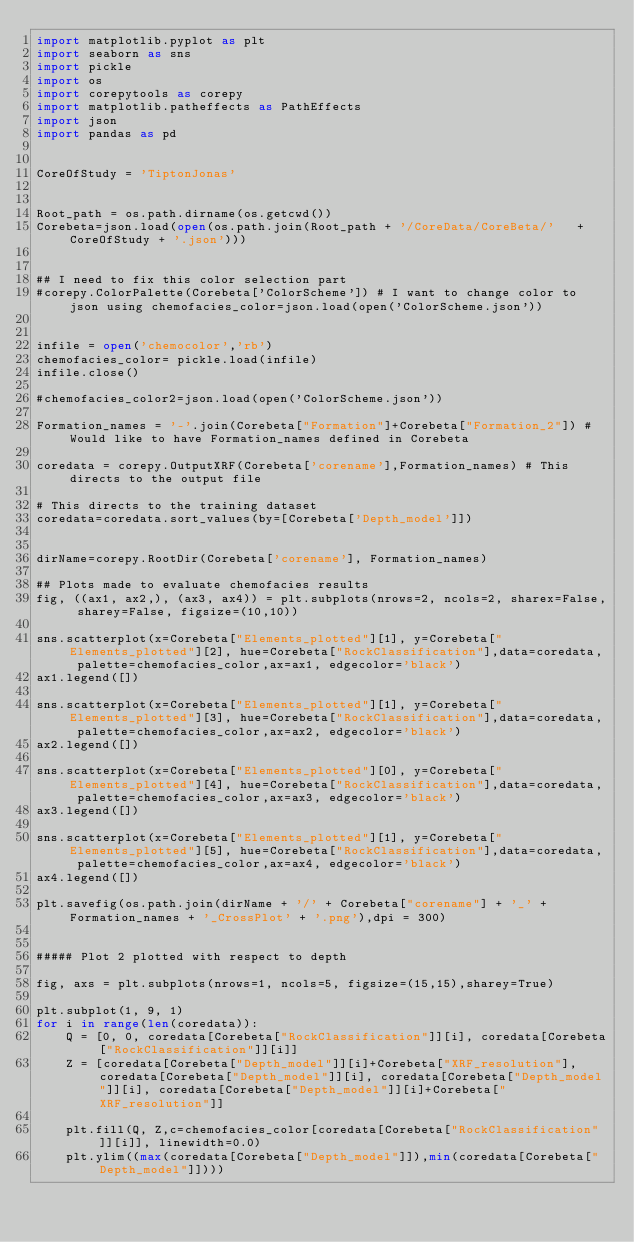Convert code to text. <code><loc_0><loc_0><loc_500><loc_500><_Python_>import matplotlib.pyplot as plt
import seaborn as sns
import pickle
import os
import corepytools as corepy
import matplotlib.patheffects as PathEffects
import json
import pandas as pd


CoreOfStudy = 'TiptonJonas'


Root_path = os.path.dirname(os.getcwd())
Corebeta=json.load(open(os.path.join(Root_path + '/CoreData/CoreBeta/'   +  CoreOfStudy + '.json')))


## I need to fix this color selection part
#corepy.ColorPalette(Corebeta['ColorScheme']) # I want to change color to json using chemofacies_color=json.load(open('ColorScheme.json'))


infile = open('chemocolor','rb')
chemofacies_color= pickle.load(infile)
infile.close()  

#chemofacies_color2=json.load(open('ColorScheme.json'))

Formation_names = '-'.join(Corebeta["Formation"]+Corebeta["Formation_2"]) # Would like to have Formation_names defined in Corebeta

coredata = corepy.OutputXRF(Corebeta['corename'],Formation_names) # This directs to the output file

# This directs to the training dataset
coredata=coredata.sort_values(by=[Corebeta['Depth_model']])


dirName=corepy.RootDir(Corebeta['corename'], Formation_names) 

## Plots made to evaluate chemofacies results 
fig, ((ax1, ax2,), (ax3, ax4)) = plt.subplots(nrows=2, ncols=2, sharex=False, sharey=False, figsize=(10,10))

sns.scatterplot(x=Corebeta["Elements_plotted"][1], y=Corebeta["Elements_plotted"][2], hue=Corebeta["RockClassification"],data=coredata, palette=chemofacies_color,ax=ax1, edgecolor='black')
ax1.legend([])

sns.scatterplot(x=Corebeta["Elements_plotted"][1], y=Corebeta["Elements_plotted"][3], hue=Corebeta["RockClassification"],data=coredata, palette=chemofacies_color,ax=ax2, edgecolor='black')
ax2.legend([])

sns.scatterplot(x=Corebeta["Elements_plotted"][0], y=Corebeta["Elements_plotted"][4], hue=Corebeta["RockClassification"],data=coredata, palette=chemofacies_color,ax=ax3, edgecolor='black')
ax3.legend([])

sns.scatterplot(x=Corebeta["Elements_plotted"][1], y=Corebeta["Elements_plotted"][5], hue=Corebeta["RockClassification"],data=coredata, palette=chemofacies_color,ax=ax4, edgecolor='black')
ax4.legend([])

plt.savefig(os.path.join(dirName + '/' + Corebeta["corename"] + '_' + Formation_names + '_CrossPlot' + '.png'),dpi = 300)


##### Plot 2 plotted with respect to depth

fig, axs = plt.subplots(nrows=1, ncols=5, figsize=(15,15),sharey=True)

plt.subplot(1, 9, 1)
for i in range(len(coredata)):
    Q = [0, 0, coredata[Corebeta["RockClassification"]][i], coredata[Corebeta["RockClassification"]][i]]
    Z = [coredata[Corebeta["Depth_model"]][i]+Corebeta["XRF_resolution"], coredata[Corebeta["Depth_model"]][i], coredata[Corebeta["Depth_model"]][i], coredata[Corebeta["Depth_model"]][i]+Corebeta["XRF_resolution"]]
       
    plt.fill(Q, Z,c=chemofacies_color[coredata[Corebeta["RockClassification"]][i]], linewidth=0.0)
    plt.ylim((max(coredata[Corebeta["Depth_model"]]),min(coredata[Corebeta["Depth_model"]])))</code> 